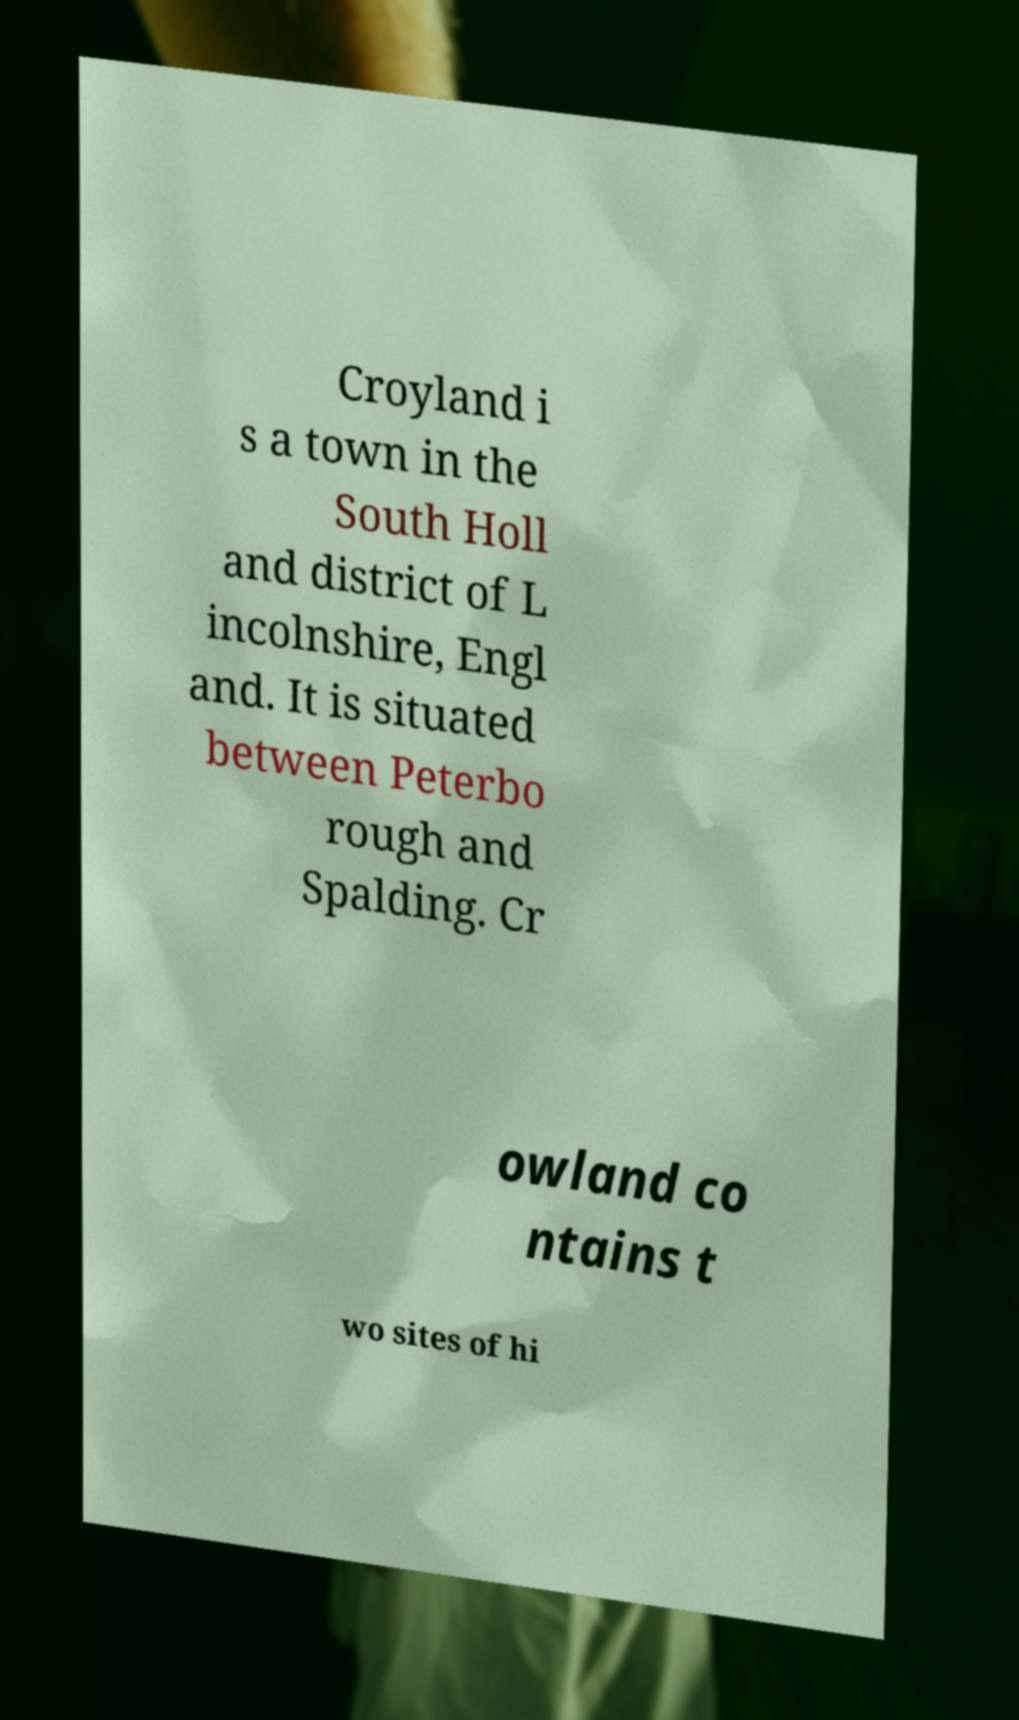Please read and relay the text visible in this image. What does it say? Croyland i s a town in the South Holl and district of L incolnshire, Engl and. It is situated between Peterbo rough and Spalding. Cr owland co ntains t wo sites of hi 